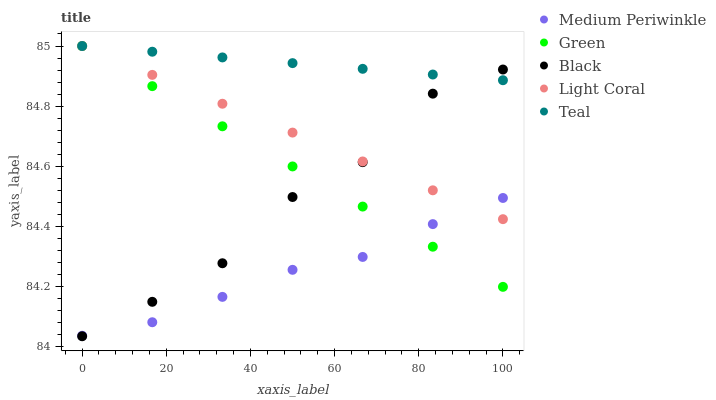Does Medium Periwinkle have the minimum area under the curve?
Answer yes or no. Yes. Does Teal have the maximum area under the curve?
Answer yes or no. Yes. Does Green have the minimum area under the curve?
Answer yes or no. No. Does Green have the maximum area under the curve?
Answer yes or no. No. Is Green the smoothest?
Answer yes or no. Yes. Is Black the roughest?
Answer yes or no. Yes. Is Medium Periwinkle the smoothest?
Answer yes or no. No. Is Medium Periwinkle the roughest?
Answer yes or no. No. Does Black have the lowest value?
Answer yes or no. Yes. Does Green have the lowest value?
Answer yes or no. No. Does Teal have the highest value?
Answer yes or no. Yes. Does Medium Periwinkle have the highest value?
Answer yes or no. No. Is Medium Periwinkle less than Teal?
Answer yes or no. Yes. Is Teal greater than Medium Periwinkle?
Answer yes or no. Yes. Does Medium Periwinkle intersect Light Coral?
Answer yes or no. Yes. Is Medium Periwinkle less than Light Coral?
Answer yes or no. No. Is Medium Periwinkle greater than Light Coral?
Answer yes or no. No. Does Medium Periwinkle intersect Teal?
Answer yes or no. No. 